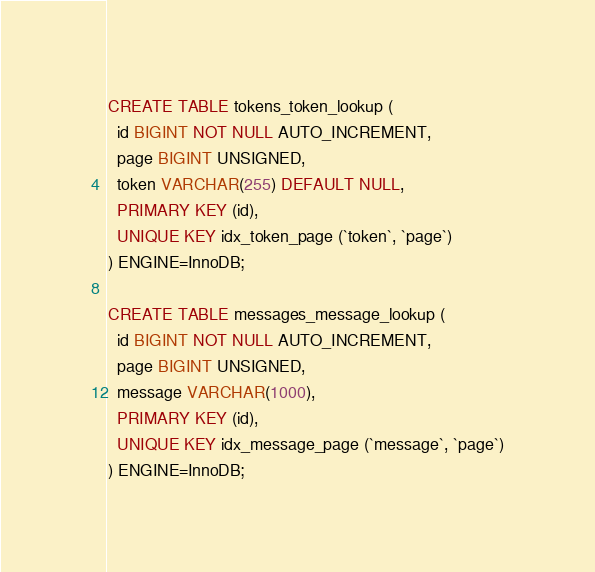<code> <loc_0><loc_0><loc_500><loc_500><_SQL_>CREATE TABLE tokens_token_lookup (
  id BIGINT NOT NULL AUTO_INCREMENT,
  page BIGINT UNSIGNED,
  token VARCHAR(255) DEFAULT NULL,
  PRIMARY KEY (id),
  UNIQUE KEY idx_token_page (`token`, `page`)
) ENGINE=InnoDB;

CREATE TABLE messages_message_lookup (
  id BIGINT NOT NULL AUTO_INCREMENT,
  page BIGINT UNSIGNED,
  message VARCHAR(1000),
  PRIMARY KEY (id),
  UNIQUE KEY idx_message_page (`message`, `page`)
) ENGINE=InnoDB;

</code> 